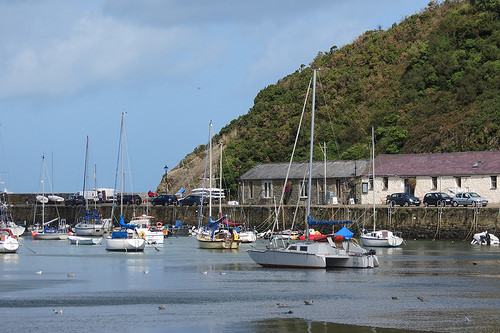<image>
Is there a boat to the right of the boat? Yes. From this viewpoint, the boat is positioned to the right side relative to the boat. Where is the boat in relation to the water? Is it in the water? Yes. The boat is contained within or inside the water, showing a containment relationship. 